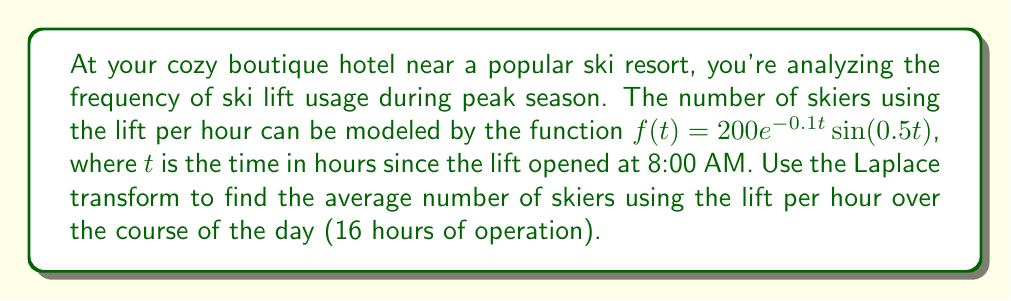Could you help me with this problem? Let's approach this step-by-step:

1) First, we need to find the Laplace transform of $f(t)$. The Laplace transform of $f(t) = 200e^{-0.1t}\sin(0.5t)$ is:

   $$F(s) = \mathcal{L}\{f(t)\} = \frac{200 \cdot 0.5}{(s+0.1)^2 + 0.5^2}$$

2) To find the average over the 16-hour period, we need to use the Final Value Theorem. However, we first need to modify our function to represent the average:

   $$g(t) = \frac{1}{t}\int_0^t f(\tau)d\tau$$

3) The Laplace transform of $g(t)$ is related to $F(s)$ as follows:

   $$G(s) = \frac{F(s)}{s}$$

4) Therefore:

   $$G(s) = \frac{200 \cdot 0.5}{s((s+0.1)^2 + 0.5^2)}$$

5) Now, we can apply the Final Value Theorem:

   $$\lim_{t \to \infty} g(t) = \lim_{s \to 0} sG(s)$$

6) Calculating this limit:

   $$\lim_{s \to 0} s \cdot \frac{200 \cdot 0.5}{s((s+0.1)^2 + 0.5^2)} = \frac{200 \cdot 0.5}{(0.1)^2 + 0.5^2} = \frac{100}{0.26} \approx 384.62$$

7) This result represents the average number of skiers per hour over an infinite time period. However, we're interested in the 16-hour period. The difference is negligible in this case, as the exponential decay in the original function means that the function approaches zero well before 16 hours.
Answer: The average number of skiers using the lift per hour over the course of the 16-hour day is approximately 385 skiers per hour. 